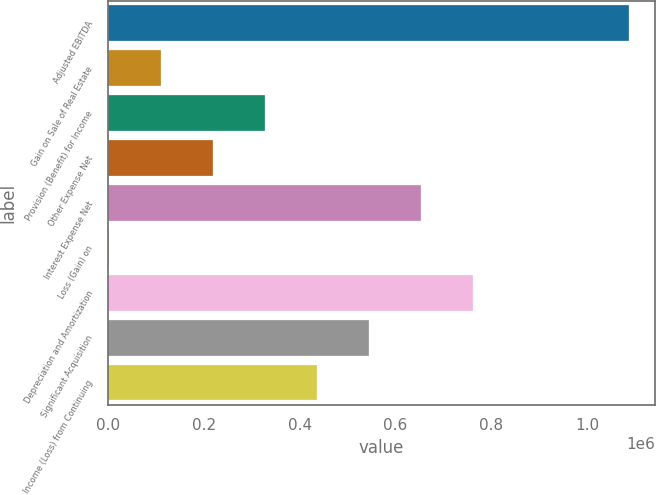<chart> <loc_0><loc_0><loc_500><loc_500><bar_chart><fcel>Adjusted EBITDA<fcel>Gain on Sale of Real Estate<fcel>Provision (Benefit) for Income<fcel>Other Expense Net<fcel>Interest Expense Net<fcel>Loss (Gain) on<fcel>Depreciation and Amortization<fcel>Significant Acquisition<fcel>Income (Loss) from Continuing<nl><fcel>1.08729e+06<fcel>110000<fcel>327175<fcel>218587<fcel>652938<fcel>1412<fcel>761525<fcel>544350<fcel>435762<nl></chart> 